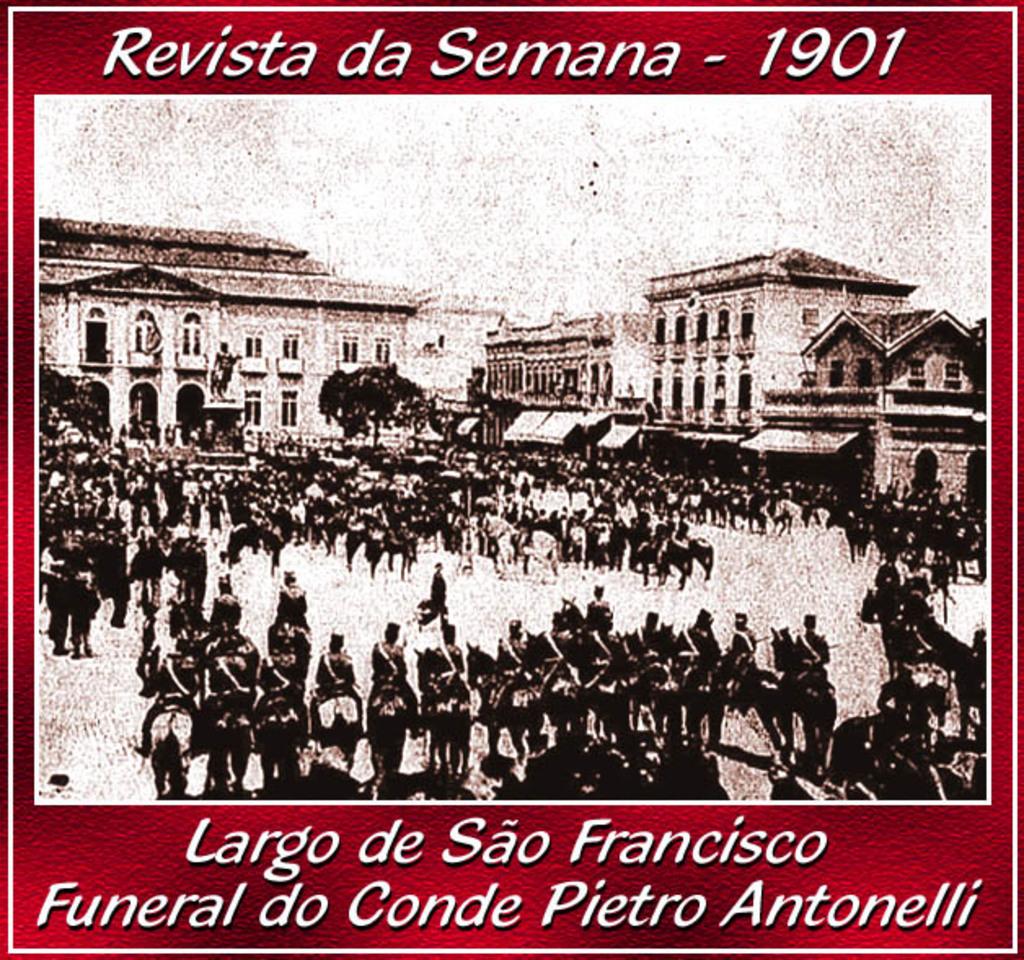What year is the picture?
Your response must be concise. 1901. What is the name of the picture?
Offer a very short reply. Revista da semana - 1901. 